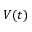<formula> <loc_0><loc_0><loc_500><loc_500>V ( t )</formula> 